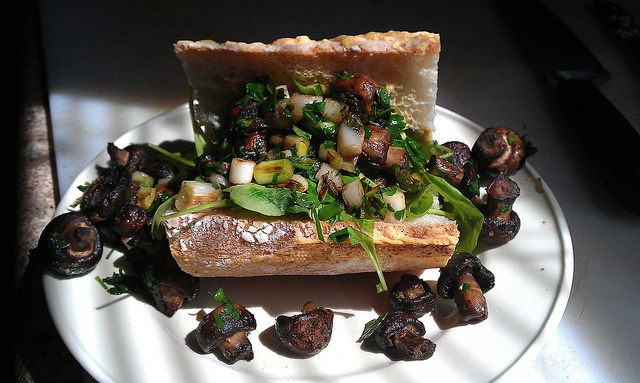Describe the objects in this image and their specific colors. I can see dining table in black, white, gray, and darkgray tones, sandwich in black, maroon, olive, and gray tones, and knife in black tones in this image. 